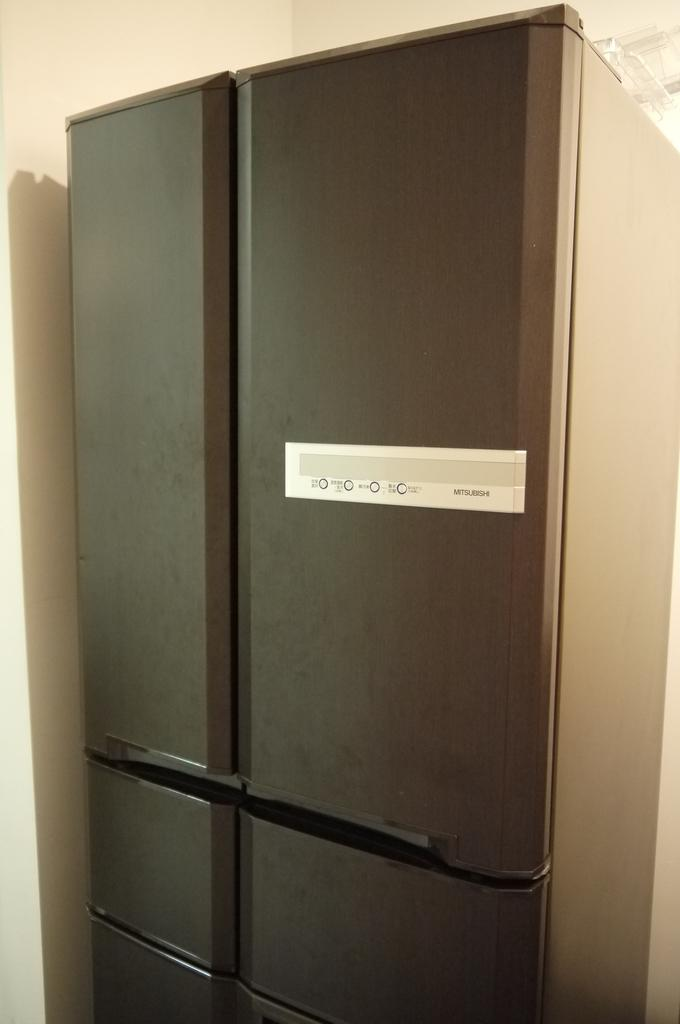Provide a one-sentence caption for the provided image. A large metal colored fridge from the company Mitsubishi. 